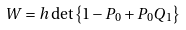Convert formula to latex. <formula><loc_0><loc_0><loc_500><loc_500>W = h \det \left \{ 1 - P _ { 0 } + P _ { 0 } Q _ { 1 } \right \}</formula> 